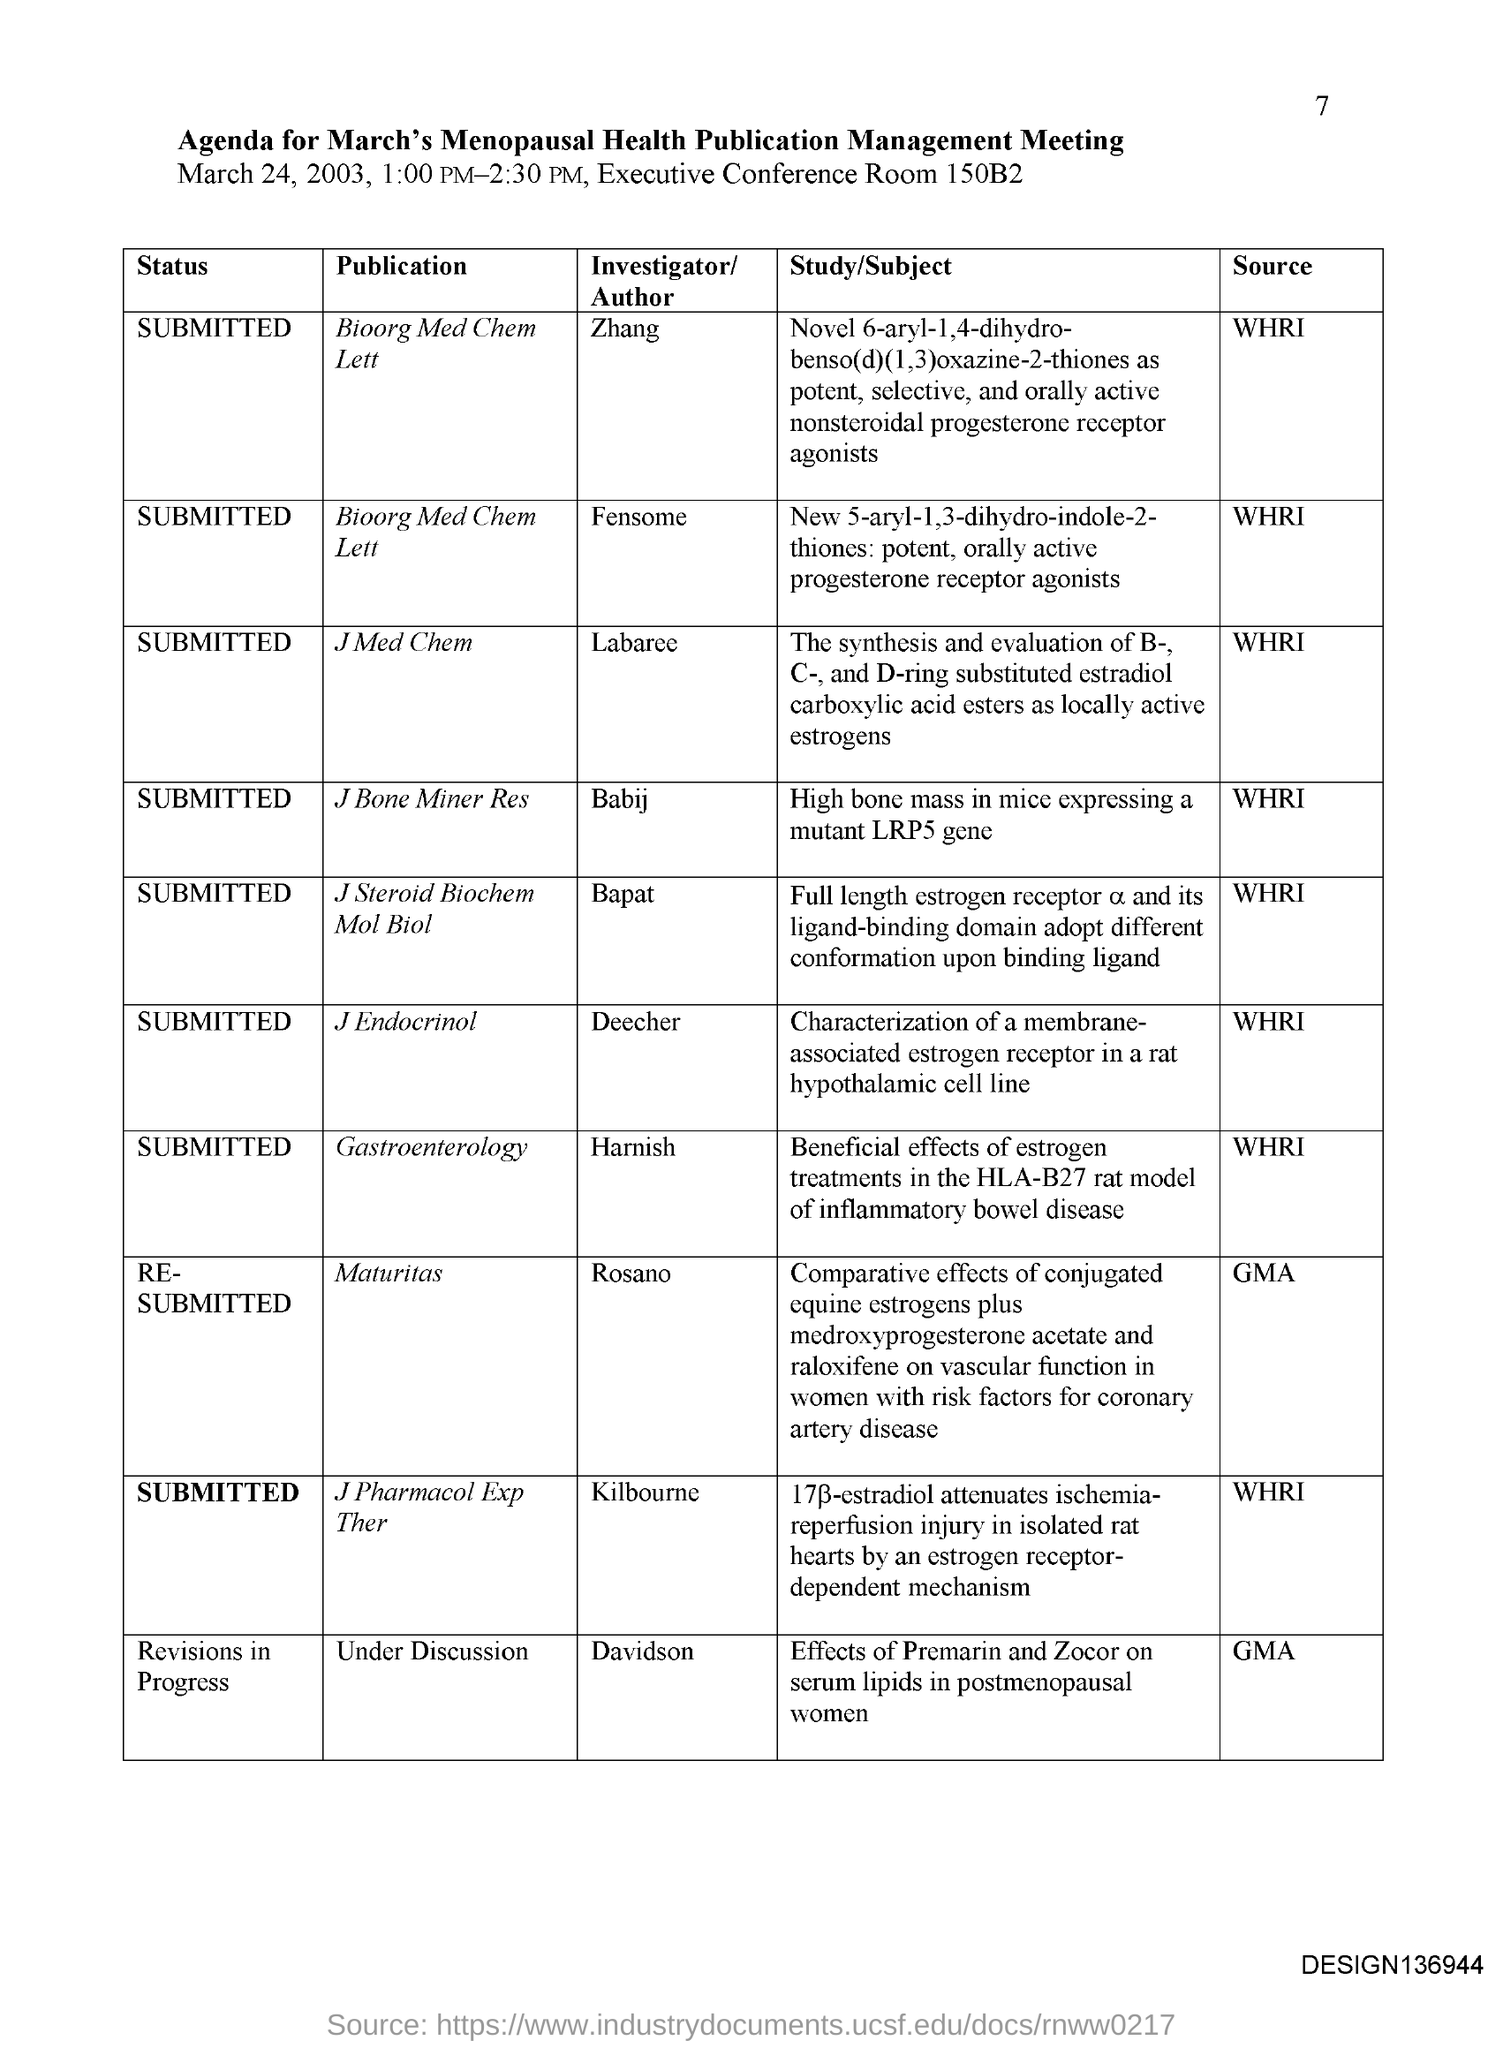Who is the investigator for the Publication "J Bone Miner Res"? The investigator for the publication listed under 'J Bone Miner Res' is Babij, as documented in the agenda for a Menopausal Health Publication Management Meeting. The document specifies that the study conducted by Babij relates to 'High bone mass in mice expressing a mutant LRP5 gene'. 